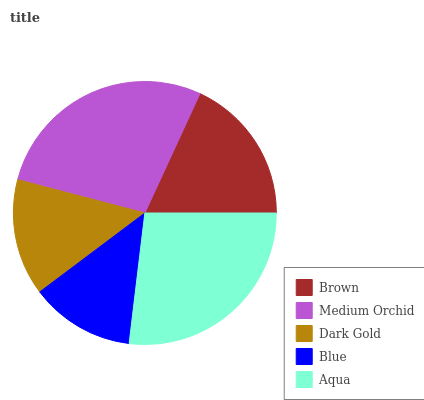Is Blue the minimum?
Answer yes or no. Yes. Is Medium Orchid the maximum?
Answer yes or no. Yes. Is Dark Gold the minimum?
Answer yes or no. No. Is Dark Gold the maximum?
Answer yes or no. No. Is Medium Orchid greater than Dark Gold?
Answer yes or no. Yes. Is Dark Gold less than Medium Orchid?
Answer yes or no. Yes. Is Dark Gold greater than Medium Orchid?
Answer yes or no. No. Is Medium Orchid less than Dark Gold?
Answer yes or no. No. Is Brown the high median?
Answer yes or no. Yes. Is Brown the low median?
Answer yes or no. Yes. Is Blue the high median?
Answer yes or no. No. Is Blue the low median?
Answer yes or no. No. 